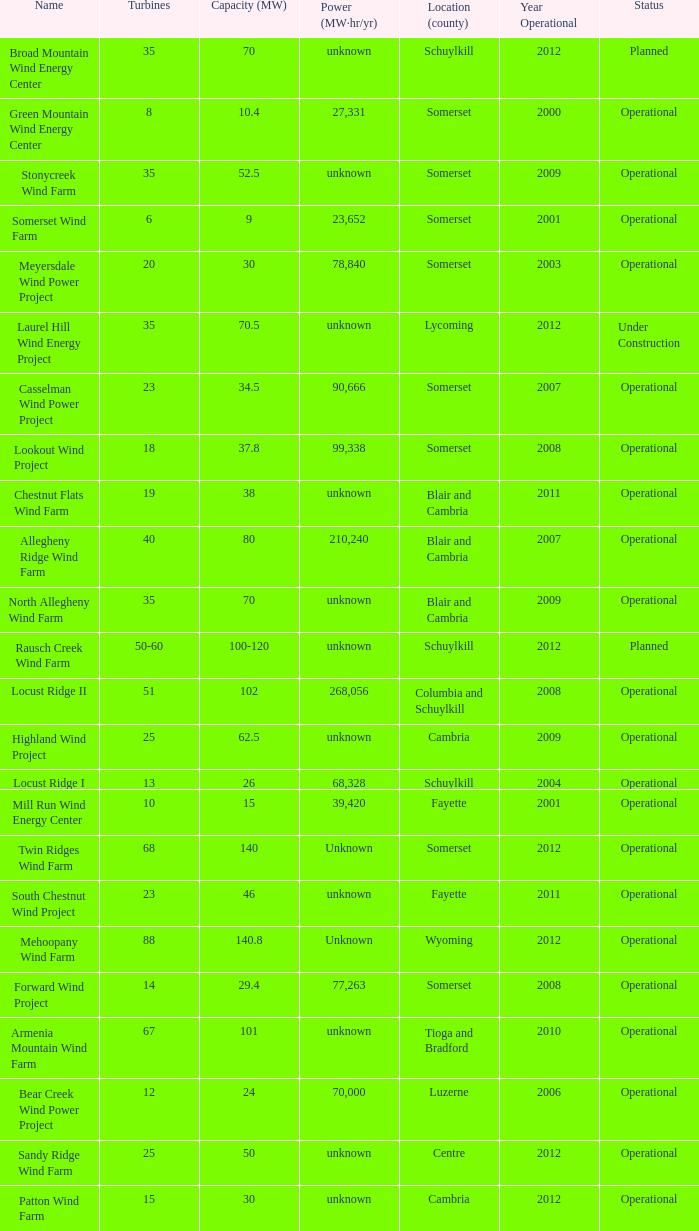What farm has a capacity of 70 and is operational? North Allegheny Wind Farm. 